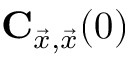Convert formula to latex. <formula><loc_0><loc_0><loc_500><loc_500>C _ { \vec { x } , \vec { x } } ( 0 )</formula> 